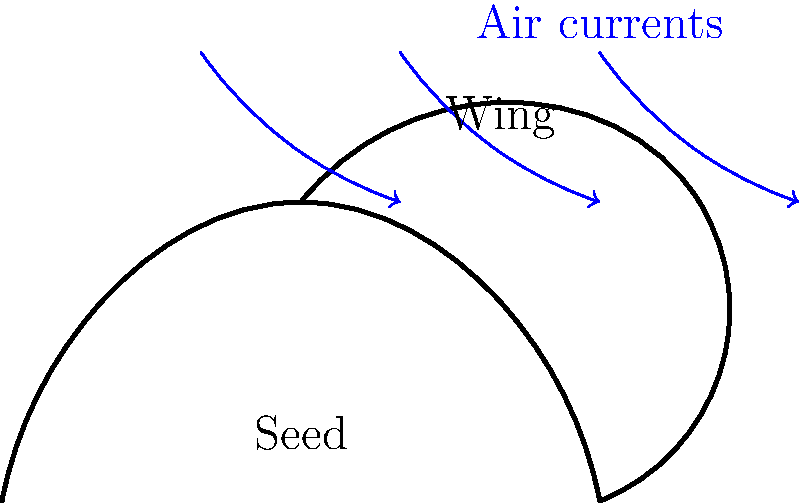As the maple seed descends, it spins in a characteristic pattern. What physical principle primarily explains the seed's ability to stay aloft longer and disperse further from the parent tree? To understand the aerodynamics of a maple seed's spinning descent, let's break it down step-by-step:

1. Shape: The maple seed has an asymmetrical shape with a small, dense seed attached to a thin, elongated wing.

2. Rotation: As the seed falls, its shape causes it to rotate around its center of mass.

3. Lift generation: The rotation creates a difference in air pressure between the upper and lower surfaces of the wing.

4. Bernoulli's principle: The wing's curved shape causes air to move faster over the top surface, creating lower pressure above the wing than below it.

5. Resulting force: This pressure difference generates an upward force (lift) perpendicular to the direction of air flow.

6. Autorotation: The lift force, combined with the seed's rotation, creates a stable autorotation similar to a helicopter's rotor.

7. Reduced descent speed: The autorotation significantly slows the seed's fall, allowing it to stay aloft longer.

8. Increased dispersal: The slower descent and spinning motion enable the seed to travel further horizontally before reaching the ground.

The primary physical principle at work here is the generation of lift through the wing's shape and rotation, explained by Bernoulli's principle and the concept of autorotation.
Answer: Lift generation through autorotation 